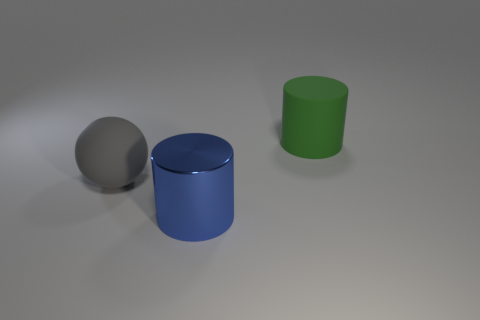Add 3 big brown rubber cylinders. How many objects exist? 6 Subtract 1 cylinders. How many cylinders are left? 1 Subtract all purple balls. Subtract all purple cylinders. How many balls are left? 1 Subtract all blue spheres. How many purple cylinders are left? 0 Subtract all large blue cylinders. Subtract all gray spheres. How many objects are left? 1 Add 2 big green rubber cylinders. How many big green rubber cylinders are left? 3 Add 2 large green matte things. How many large green matte things exist? 3 Subtract all green cylinders. How many cylinders are left? 1 Subtract 0 gray cylinders. How many objects are left? 3 Subtract all spheres. How many objects are left? 2 